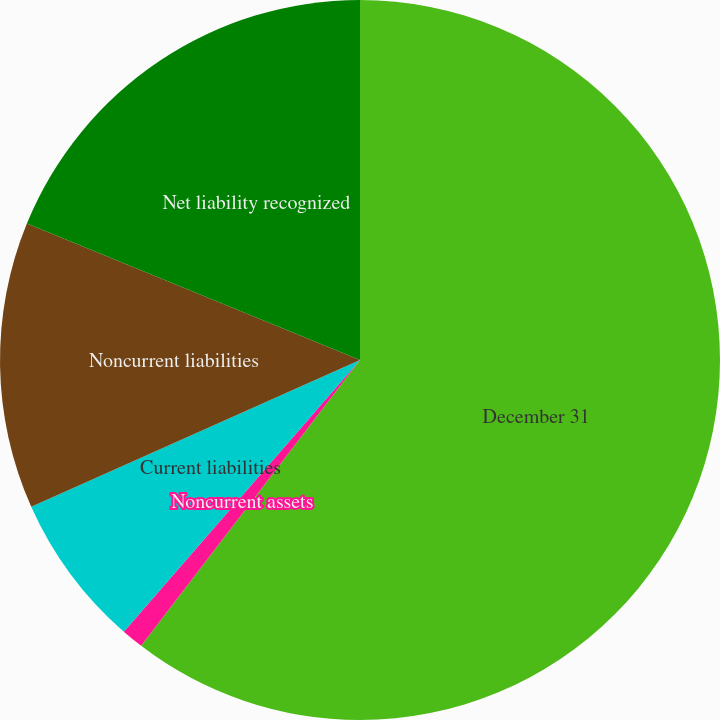Convert chart. <chart><loc_0><loc_0><loc_500><loc_500><pie_chart><fcel>December 31<fcel>Noncurrent assets<fcel>Current liabilities<fcel>Noncurrent liabilities<fcel>Net liability recognized<nl><fcel>60.4%<fcel>0.99%<fcel>6.93%<fcel>12.87%<fcel>18.81%<nl></chart> 